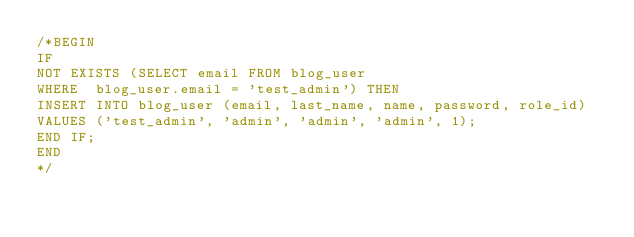<code> <loc_0><loc_0><loc_500><loc_500><_SQL_>/*BEGIN
IF
NOT EXISTS (SELECT email FROM blog_user
WHERE  blog_user.email = 'test_admin') THEN
INSERT INTO blog_user (email, last_name, name, password, role_id)
VALUES ('test_admin', 'admin', 'admin', 'admin', 1);
END IF;
END
*/</code> 